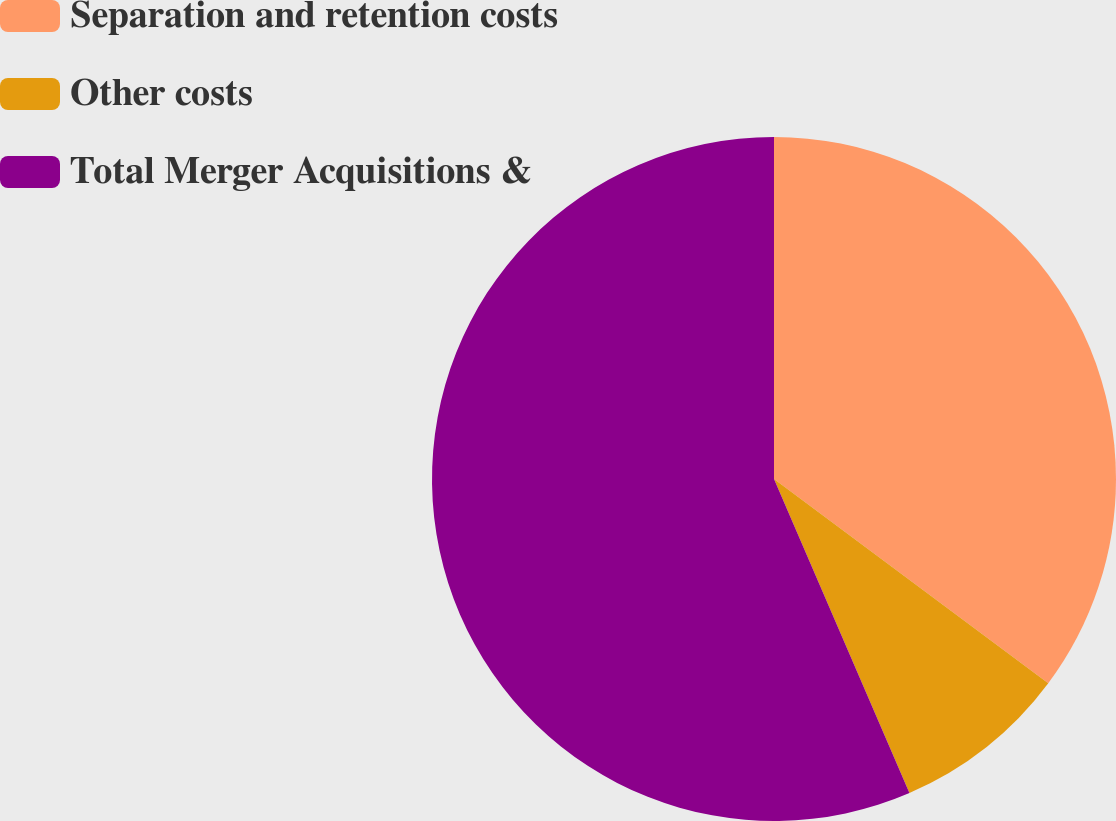Convert chart to OTSL. <chart><loc_0><loc_0><loc_500><loc_500><pie_chart><fcel>Separation and retention costs<fcel>Other costs<fcel>Total Merger Acquisitions &<nl><fcel>35.19%<fcel>8.33%<fcel>56.48%<nl></chart> 